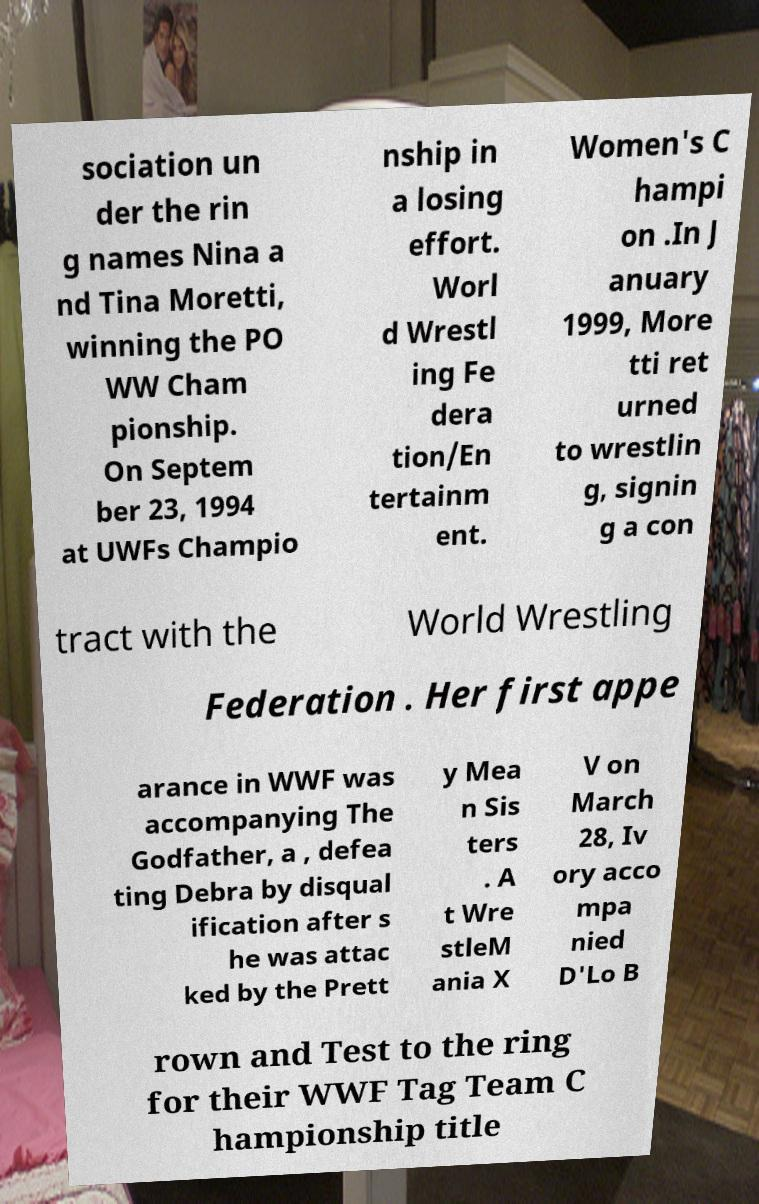Could you extract and type out the text from this image? sociation un der the rin g names Nina a nd Tina Moretti, winning the PO WW Cham pionship. On Septem ber 23, 1994 at UWFs Champio nship in a losing effort. Worl d Wrestl ing Fe dera tion/En tertainm ent. Women's C hampi on .In J anuary 1999, More tti ret urned to wrestlin g, signin g a con tract with the World Wrestling Federation . Her first appe arance in WWF was accompanying The Godfather, a , defea ting Debra by disqual ification after s he was attac ked by the Prett y Mea n Sis ters . A t Wre stleM ania X V on March 28, Iv ory acco mpa nied D'Lo B rown and Test to the ring for their WWF Tag Team C hampionship title 